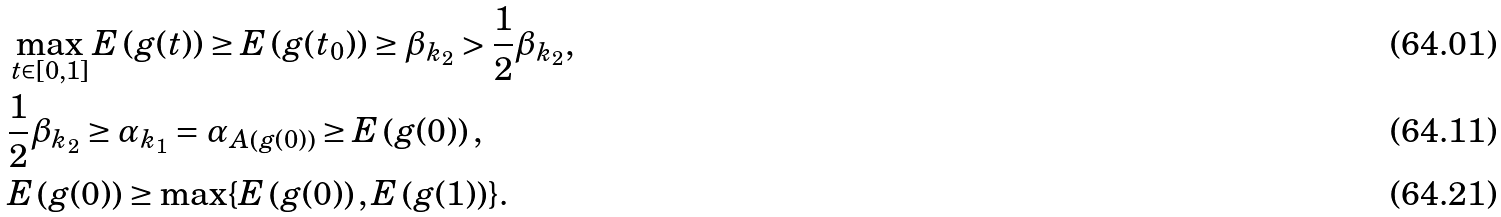Convert formula to latex. <formula><loc_0><loc_0><loc_500><loc_500>& \max _ { t \in [ 0 , 1 ] } E \left ( g ( t ) \right ) \geq E \left ( g ( t _ { 0 } ) \right ) \geq \beta _ { k _ { 2 } } > \frac { 1 } { 2 } \beta _ { k _ { 2 } } , \\ & \frac { 1 } { 2 } \beta _ { k _ { 2 } } \geq \alpha _ { k _ { 1 } } = \alpha _ { A \left ( g ( 0 ) \right ) } \geq E \left ( g ( 0 ) \right ) , \\ & E \left ( g ( 0 ) \right ) \geq \max \{ E \left ( g ( 0 ) \right ) , E \left ( g ( 1 ) \right ) \} .</formula> 